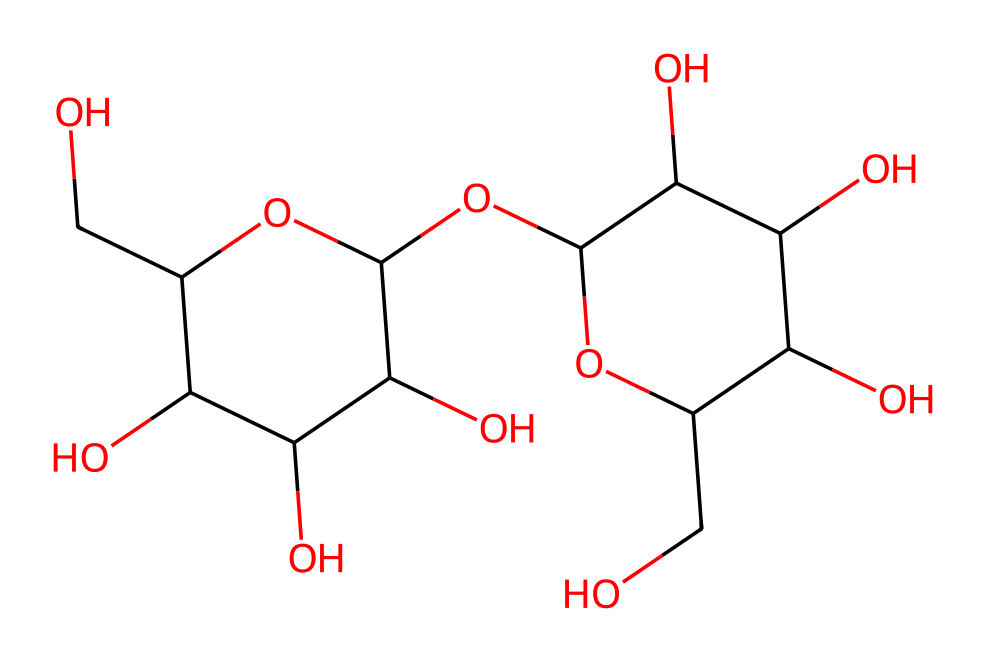What is the primary component of this non-Newtonian fluid? The chemical structure represents a polysaccharide, specifically a form of starch, which is primarily composed of glucose units.
Answer: polysaccharide How many hydroxyl groups are present in this chemical? By examining the structure, there are a total of 6 hydroxyl (-OH) groups attached to the glucose units in the structure.
Answer: 6 What is the molecular formula represented by this SMILES? The SMILES suggests that the compound is formed from several glucose monosaccharides, leading to the molecular formula C12H22O11.
Answer: C12H22O11 Why does this cornstarch-based non-Newtonian fluid behave like a solid under stress? The high concentration of starch links the molecules, creating a network that can resist flow under stress, resulting in solid-like behavior, commonly known as shear-thickening.
Answer: shear-thickening How does the presence of water affect the viscosity of this fluid? When water is added to the starch, it disrupts the intermolecular interactions between starch chains, which leads to a decrease in viscosity, making it flow more easily.
Answer: decreases viscosity What property of this non-Newtonian fluid allows it to demonstrate vibrations? The unique property of shear-thickening enables it to absorb and respond to energy input from vibrations, causing it to behave differently than regular fluids under dynamic conditions.
Answer: shear-thickening How does temperature influence the behavior of this non-Newtonian fluid? Increased temperature can affect the viscosity and elasticity of the fluid, causing it to behave more like a traditional liquid compared to its colder state, where it is more solid-like under stress.
Answer: affects viscosity and elasticity 